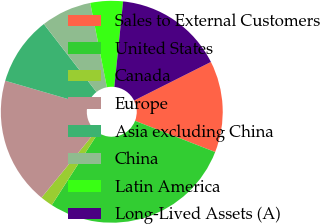<chart> <loc_0><loc_0><loc_500><loc_500><pie_chart><fcel>Sales to External Customers<fcel>United States<fcel>Canada<fcel>Europe<fcel>Asia excluding China<fcel>China<fcel>Latin America<fcel>Long-Lived Assets (A)<nl><fcel>13.32%<fcel>28.18%<fcel>1.82%<fcel>18.59%<fcel>10.01%<fcel>7.37%<fcel>4.74%<fcel>15.96%<nl></chart> 